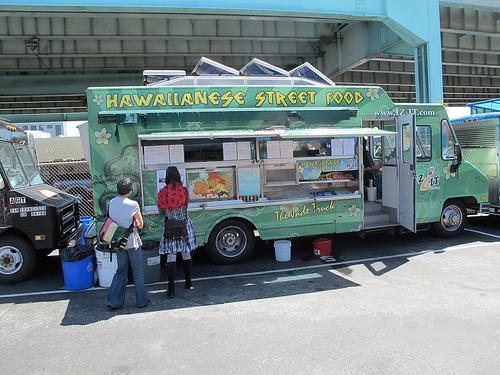Count the number of trash cans, buckets, and tires in the image. There are 3 trash cans, 3 buckets, and 3 tires in the image. What is happening in the street scene in this image? There is a food truck parked on the street, a woman standing beside it, and people ordering food from it, while a green food truck and a black van can also be seen parked behind. What type of building do you see in this image and where it is located in relation to the food truck? A building can be seen behind the food truck, possibly a commercial or residential property given its urban setting. Identify the different types of vehicles in the image and their colors. There is a green food truck, a black van, and another brown food truck parked behind trash cans. Give me a brief description of the colors and main objects in the scene. The scene features a green food truck with yellow letters and an open door, a black van, multi-colored garbage cans, and a woman in a skirt, along with tires, buckets, and solar panels. How are the environment and trash managed in this street scene? There are designated garbage cans of different colors for proper waste disposal, including a blue recycling can and a black trash bag in one of the cans. Mention an interesting detail about the food truck in the image. The food truck has solar panels on its top for a more energy-efficient and eco-friendly operation. Describe a small but noticeable detail about the garbage cans in the image. Among the garbage cans, there is a blue trash can with a black trash bag inside, possibly indicating the separation of recyclables from general waste. Analyze the sentiment expressed in the scene shown in the image. A sense of community and urban life is expressed through people interacting around a food truck, attempting to dispose of trash properly, and forming bonds on the street. What is the interaction happening between the people and the food truck in the image? People are ordering food from the food truck's service window, while a woman stands beside it, possibly waiting for her order. 